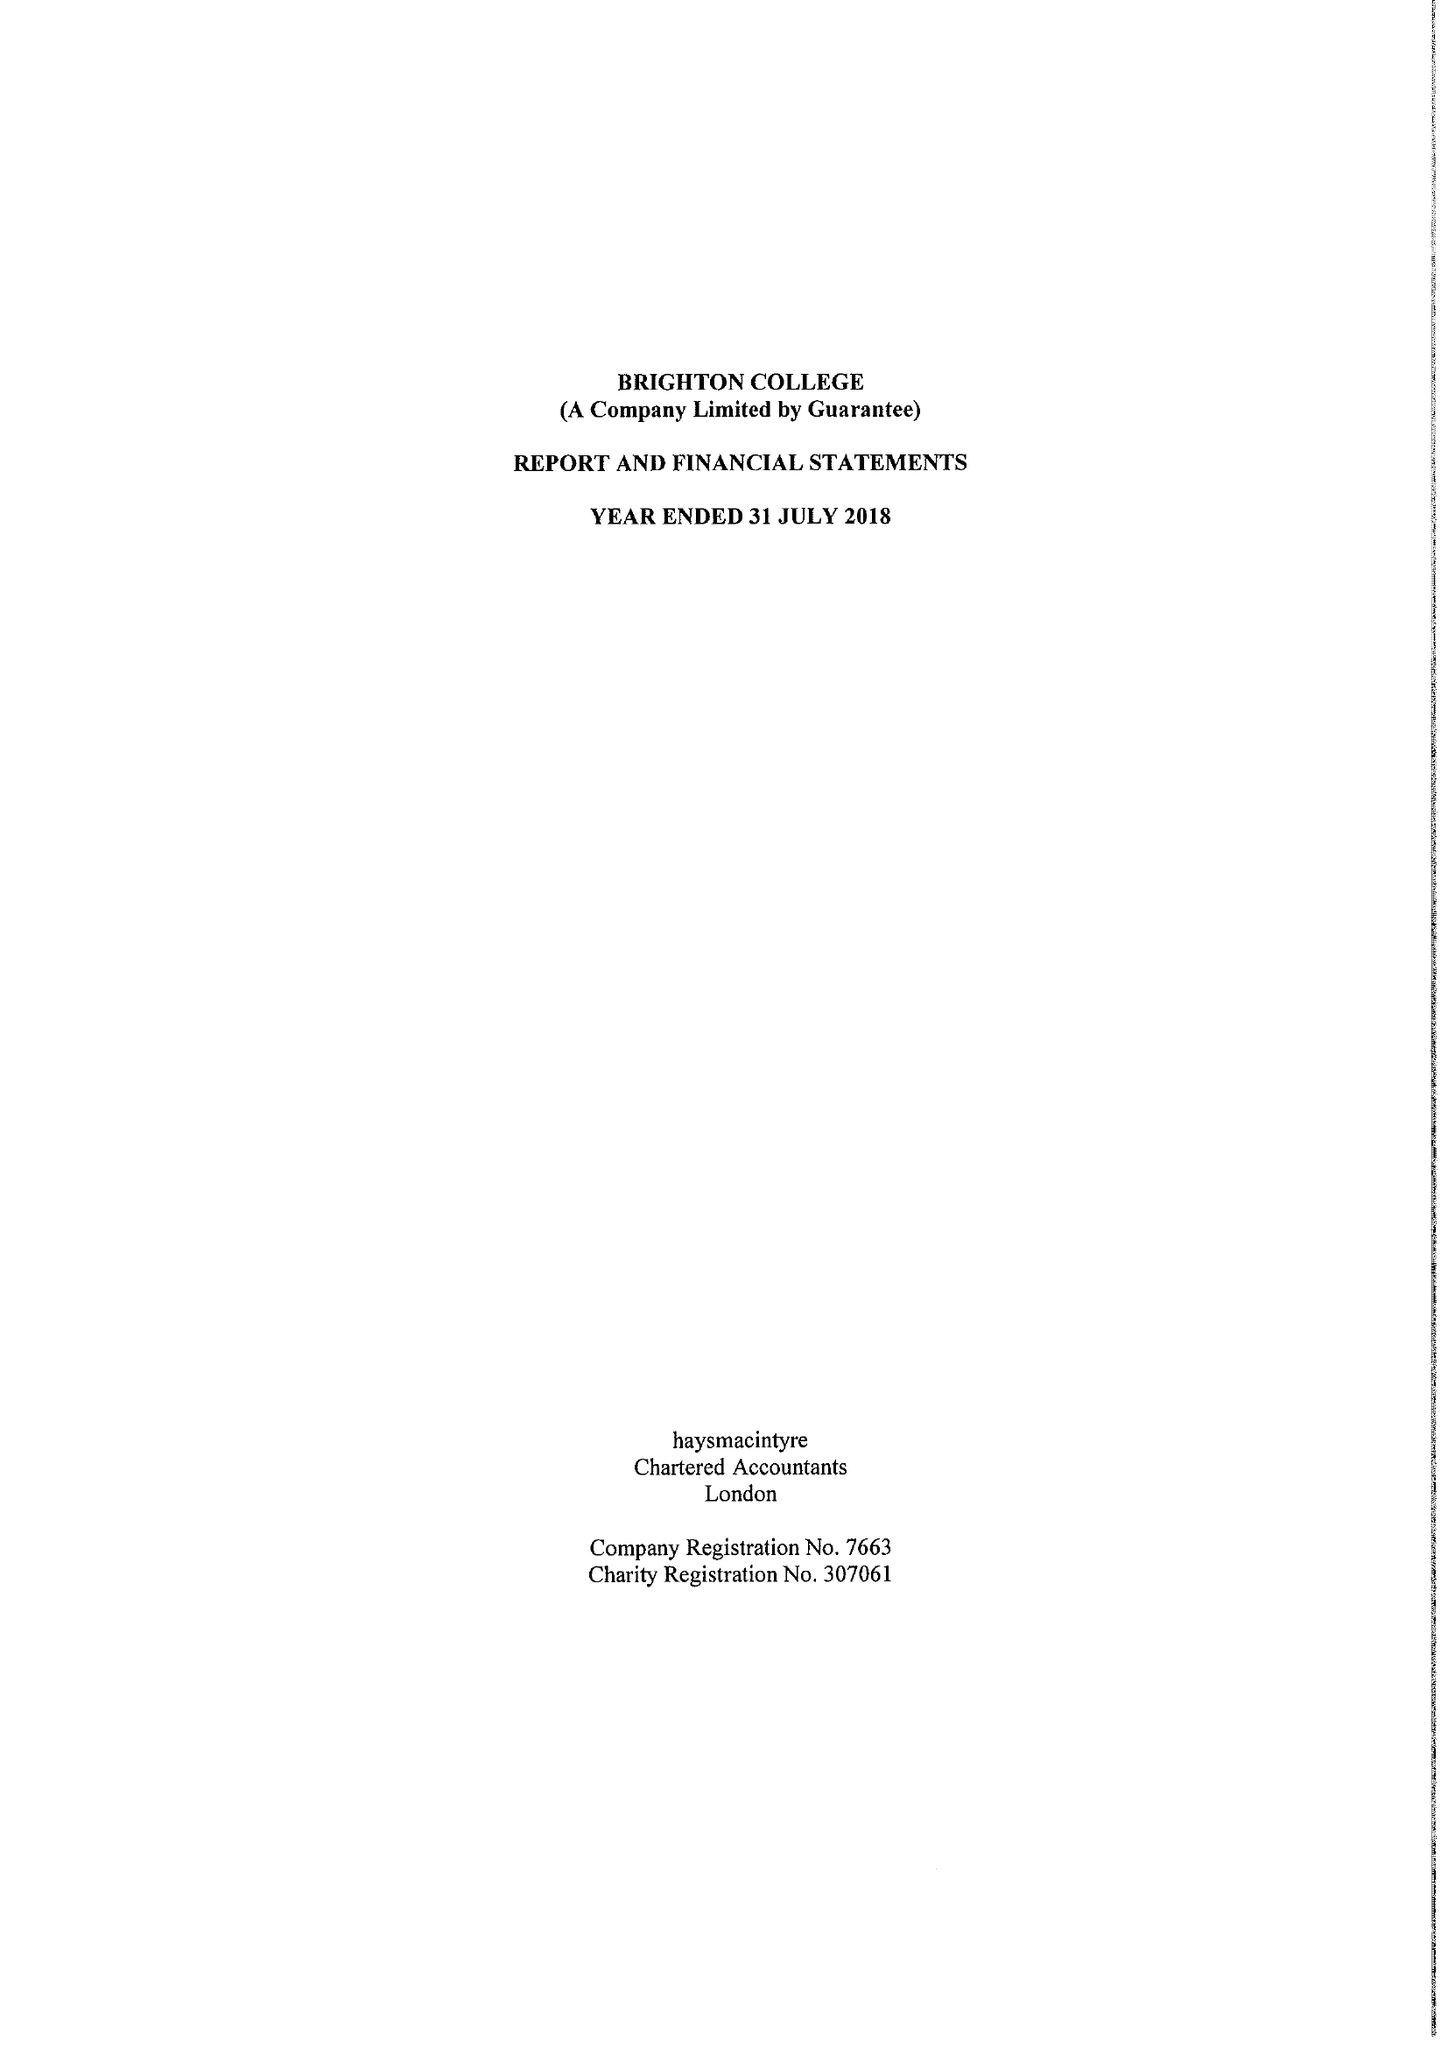What is the value for the charity_name?
Answer the question using a single word or phrase. Brighton College 